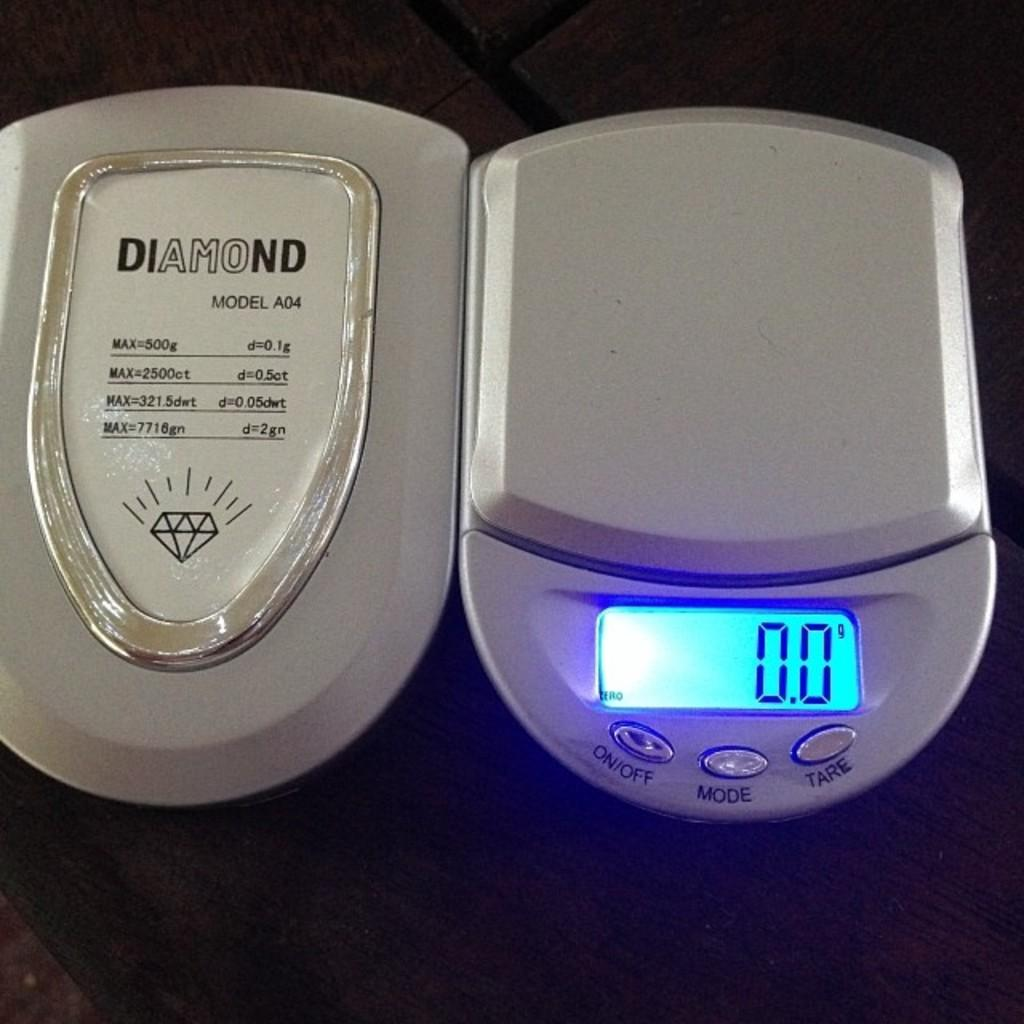Provide a one-sentence caption for the provided image. A Diamond brand scale with a digital display lit up. 